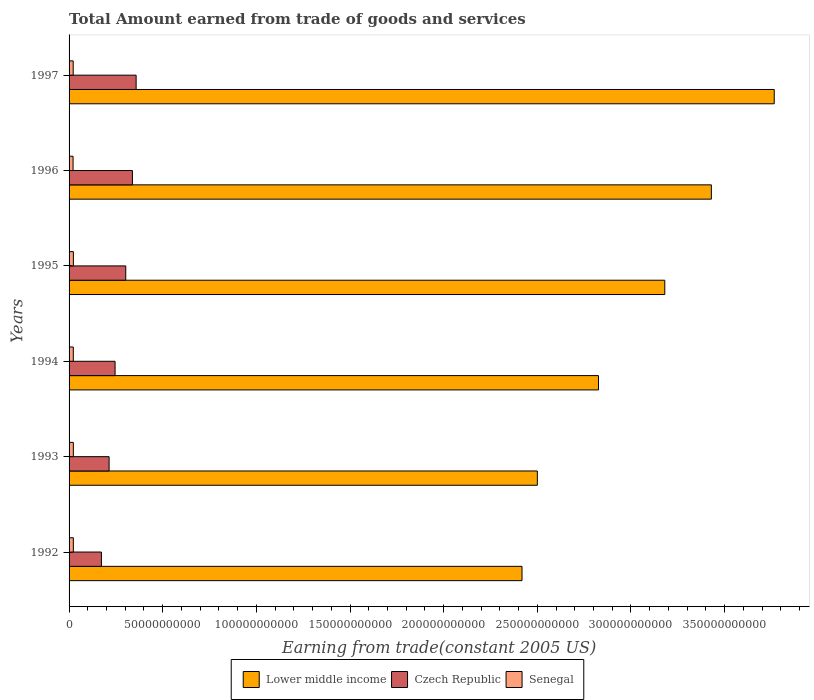How many bars are there on the 3rd tick from the bottom?
Your answer should be compact. 3. What is the total amount earned by trading goods and services in Senegal in 1996?
Offer a terse response. 2.13e+09. Across all years, what is the maximum total amount earned by trading goods and services in Lower middle income?
Provide a short and direct response. 3.76e+11. Across all years, what is the minimum total amount earned by trading goods and services in Senegal?
Keep it short and to the point. 2.13e+09. In which year was the total amount earned by trading goods and services in Lower middle income maximum?
Offer a terse response. 1997. What is the total total amount earned by trading goods and services in Senegal in the graph?
Ensure brevity in your answer.  1.34e+1. What is the difference between the total amount earned by trading goods and services in Senegal in 1993 and that in 1994?
Provide a succinct answer. 2.93e+07. What is the difference between the total amount earned by trading goods and services in Lower middle income in 1992 and the total amount earned by trading goods and services in Senegal in 1994?
Make the answer very short. 2.40e+11. What is the average total amount earned by trading goods and services in Senegal per year?
Offer a very short reply. 2.24e+09. In the year 1996, what is the difference between the total amount earned by trading goods and services in Czech Republic and total amount earned by trading goods and services in Senegal?
Offer a very short reply. 3.17e+1. What is the ratio of the total amount earned by trading goods and services in Czech Republic in 1992 to that in 1996?
Offer a very short reply. 0.51. What is the difference between the highest and the second highest total amount earned by trading goods and services in Lower middle income?
Your answer should be compact. 3.36e+1. What is the difference between the highest and the lowest total amount earned by trading goods and services in Czech Republic?
Ensure brevity in your answer.  1.85e+1. In how many years, is the total amount earned by trading goods and services in Lower middle income greater than the average total amount earned by trading goods and services in Lower middle income taken over all years?
Make the answer very short. 3. What does the 1st bar from the top in 1997 represents?
Your response must be concise. Senegal. What does the 3rd bar from the bottom in 1993 represents?
Provide a succinct answer. Senegal. Is it the case that in every year, the sum of the total amount earned by trading goods and services in Czech Republic and total amount earned by trading goods and services in Lower middle income is greater than the total amount earned by trading goods and services in Senegal?
Provide a short and direct response. Yes. Are all the bars in the graph horizontal?
Your response must be concise. Yes. What is the difference between two consecutive major ticks on the X-axis?
Your response must be concise. 5.00e+1. Are the values on the major ticks of X-axis written in scientific E-notation?
Keep it short and to the point. No. Does the graph contain any zero values?
Your response must be concise. No. Does the graph contain grids?
Make the answer very short. No. Where does the legend appear in the graph?
Offer a very short reply. Bottom center. How many legend labels are there?
Provide a succinct answer. 3. How are the legend labels stacked?
Your answer should be very brief. Horizontal. What is the title of the graph?
Make the answer very short. Total Amount earned from trade of goods and services. Does "Sudan" appear as one of the legend labels in the graph?
Provide a succinct answer. No. What is the label or title of the X-axis?
Offer a terse response. Earning from trade(constant 2005 US). What is the label or title of the Y-axis?
Your answer should be compact. Years. What is the Earning from trade(constant 2005 US) of Lower middle income in 1992?
Keep it short and to the point. 2.42e+11. What is the Earning from trade(constant 2005 US) of Czech Republic in 1992?
Your response must be concise. 1.73e+1. What is the Earning from trade(constant 2005 US) in Senegal in 1992?
Your answer should be very brief. 2.28e+09. What is the Earning from trade(constant 2005 US) in Lower middle income in 1993?
Offer a very short reply. 2.50e+11. What is the Earning from trade(constant 2005 US) of Czech Republic in 1993?
Ensure brevity in your answer.  2.14e+1. What is the Earning from trade(constant 2005 US) in Senegal in 1993?
Keep it short and to the point. 2.28e+09. What is the Earning from trade(constant 2005 US) of Lower middle income in 1994?
Make the answer very short. 2.83e+11. What is the Earning from trade(constant 2005 US) of Czech Republic in 1994?
Provide a succinct answer. 2.46e+1. What is the Earning from trade(constant 2005 US) in Senegal in 1994?
Ensure brevity in your answer.  2.25e+09. What is the Earning from trade(constant 2005 US) of Lower middle income in 1995?
Make the answer very short. 3.18e+11. What is the Earning from trade(constant 2005 US) in Czech Republic in 1995?
Provide a succinct answer. 3.03e+1. What is the Earning from trade(constant 2005 US) in Senegal in 1995?
Give a very brief answer. 2.29e+09. What is the Earning from trade(constant 2005 US) of Lower middle income in 1996?
Your response must be concise. 3.43e+11. What is the Earning from trade(constant 2005 US) of Czech Republic in 1996?
Offer a terse response. 3.38e+1. What is the Earning from trade(constant 2005 US) in Senegal in 1996?
Ensure brevity in your answer.  2.13e+09. What is the Earning from trade(constant 2005 US) in Lower middle income in 1997?
Make the answer very short. 3.76e+11. What is the Earning from trade(constant 2005 US) of Czech Republic in 1997?
Your answer should be very brief. 3.58e+1. What is the Earning from trade(constant 2005 US) of Senegal in 1997?
Provide a succinct answer. 2.20e+09. Across all years, what is the maximum Earning from trade(constant 2005 US) in Lower middle income?
Your response must be concise. 3.76e+11. Across all years, what is the maximum Earning from trade(constant 2005 US) of Czech Republic?
Your response must be concise. 3.58e+1. Across all years, what is the maximum Earning from trade(constant 2005 US) in Senegal?
Your answer should be very brief. 2.29e+09. Across all years, what is the minimum Earning from trade(constant 2005 US) of Lower middle income?
Give a very brief answer. 2.42e+11. Across all years, what is the minimum Earning from trade(constant 2005 US) in Czech Republic?
Your answer should be compact. 1.73e+1. Across all years, what is the minimum Earning from trade(constant 2005 US) of Senegal?
Keep it short and to the point. 2.13e+09. What is the total Earning from trade(constant 2005 US) in Lower middle income in the graph?
Provide a short and direct response. 1.81e+12. What is the total Earning from trade(constant 2005 US) in Czech Republic in the graph?
Your answer should be very brief. 1.63e+11. What is the total Earning from trade(constant 2005 US) in Senegal in the graph?
Keep it short and to the point. 1.34e+1. What is the difference between the Earning from trade(constant 2005 US) of Lower middle income in 1992 and that in 1993?
Give a very brief answer. -8.19e+09. What is the difference between the Earning from trade(constant 2005 US) in Czech Republic in 1992 and that in 1993?
Provide a short and direct response. -4.10e+09. What is the difference between the Earning from trade(constant 2005 US) in Senegal in 1992 and that in 1993?
Your response must be concise. -6.57e+06. What is the difference between the Earning from trade(constant 2005 US) of Lower middle income in 1992 and that in 1994?
Offer a terse response. -4.08e+1. What is the difference between the Earning from trade(constant 2005 US) in Czech Republic in 1992 and that in 1994?
Offer a very short reply. -7.30e+09. What is the difference between the Earning from trade(constant 2005 US) in Senegal in 1992 and that in 1994?
Provide a short and direct response. 2.27e+07. What is the difference between the Earning from trade(constant 2005 US) of Lower middle income in 1992 and that in 1995?
Provide a short and direct response. -7.62e+1. What is the difference between the Earning from trade(constant 2005 US) in Czech Republic in 1992 and that in 1995?
Your answer should be compact. -1.30e+1. What is the difference between the Earning from trade(constant 2005 US) in Senegal in 1992 and that in 1995?
Keep it short and to the point. -1.78e+07. What is the difference between the Earning from trade(constant 2005 US) of Lower middle income in 1992 and that in 1996?
Your answer should be very brief. -1.01e+11. What is the difference between the Earning from trade(constant 2005 US) of Czech Republic in 1992 and that in 1996?
Your answer should be very brief. -1.66e+1. What is the difference between the Earning from trade(constant 2005 US) of Senegal in 1992 and that in 1996?
Make the answer very short. 1.47e+08. What is the difference between the Earning from trade(constant 2005 US) in Lower middle income in 1992 and that in 1997?
Your answer should be very brief. -1.35e+11. What is the difference between the Earning from trade(constant 2005 US) in Czech Republic in 1992 and that in 1997?
Keep it short and to the point. -1.85e+1. What is the difference between the Earning from trade(constant 2005 US) in Senegal in 1992 and that in 1997?
Ensure brevity in your answer.  8.05e+07. What is the difference between the Earning from trade(constant 2005 US) of Lower middle income in 1993 and that in 1994?
Offer a terse response. -3.26e+1. What is the difference between the Earning from trade(constant 2005 US) of Czech Republic in 1993 and that in 1994?
Make the answer very short. -3.20e+09. What is the difference between the Earning from trade(constant 2005 US) in Senegal in 1993 and that in 1994?
Ensure brevity in your answer.  2.93e+07. What is the difference between the Earning from trade(constant 2005 US) in Lower middle income in 1993 and that in 1995?
Make the answer very short. -6.80e+1. What is the difference between the Earning from trade(constant 2005 US) in Czech Republic in 1993 and that in 1995?
Provide a short and direct response. -8.89e+09. What is the difference between the Earning from trade(constant 2005 US) of Senegal in 1993 and that in 1995?
Ensure brevity in your answer.  -1.12e+07. What is the difference between the Earning from trade(constant 2005 US) in Lower middle income in 1993 and that in 1996?
Provide a short and direct response. -9.29e+1. What is the difference between the Earning from trade(constant 2005 US) of Czech Republic in 1993 and that in 1996?
Make the answer very short. -1.25e+1. What is the difference between the Earning from trade(constant 2005 US) of Senegal in 1993 and that in 1996?
Your response must be concise. 1.54e+08. What is the difference between the Earning from trade(constant 2005 US) in Lower middle income in 1993 and that in 1997?
Your response must be concise. -1.26e+11. What is the difference between the Earning from trade(constant 2005 US) of Czech Republic in 1993 and that in 1997?
Offer a terse response. -1.44e+1. What is the difference between the Earning from trade(constant 2005 US) in Senegal in 1993 and that in 1997?
Ensure brevity in your answer.  8.71e+07. What is the difference between the Earning from trade(constant 2005 US) of Lower middle income in 1994 and that in 1995?
Offer a terse response. -3.54e+1. What is the difference between the Earning from trade(constant 2005 US) in Czech Republic in 1994 and that in 1995?
Make the answer very short. -5.69e+09. What is the difference between the Earning from trade(constant 2005 US) in Senegal in 1994 and that in 1995?
Make the answer very short. -4.05e+07. What is the difference between the Earning from trade(constant 2005 US) in Lower middle income in 1994 and that in 1996?
Offer a terse response. -6.03e+1. What is the difference between the Earning from trade(constant 2005 US) in Czech Republic in 1994 and that in 1996?
Keep it short and to the point. -9.26e+09. What is the difference between the Earning from trade(constant 2005 US) of Senegal in 1994 and that in 1996?
Your response must be concise. 1.24e+08. What is the difference between the Earning from trade(constant 2005 US) of Lower middle income in 1994 and that in 1997?
Your response must be concise. -9.38e+1. What is the difference between the Earning from trade(constant 2005 US) of Czech Republic in 1994 and that in 1997?
Your answer should be very brief. -1.12e+1. What is the difference between the Earning from trade(constant 2005 US) in Senegal in 1994 and that in 1997?
Provide a succinct answer. 5.78e+07. What is the difference between the Earning from trade(constant 2005 US) in Lower middle income in 1995 and that in 1996?
Provide a succinct answer. -2.49e+1. What is the difference between the Earning from trade(constant 2005 US) in Czech Republic in 1995 and that in 1996?
Your answer should be very brief. -3.56e+09. What is the difference between the Earning from trade(constant 2005 US) of Senegal in 1995 and that in 1996?
Your response must be concise. 1.65e+08. What is the difference between the Earning from trade(constant 2005 US) of Lower middle income in 1995 and that in 1997?
Provide a short and direct response. -5.84e+1. What is the difference between the Earning from trade(constant 2005 US) in Czech Republic in 1995 and that in 1997?
Keep it short and to the point. -5.54e+09. What is the difference between the Earning from trade(constant 2005 US) of Senegal in 1995 and that in 1997?
Provide a short and direct response. 9.83e+07. What is the difference between the Earning from trade(constant 2005 US) in Lower middle income in 1996 and that in 1997?
Your answer should be very brief. -3.36e+1. What is the difference between the Earning from trade(constant 2005 US) in Czech Republic in 1996 and that in 1997?
Ensure brevity in your answer.  -1.97e+09. What is the difference between the Earning from trade(constant 2005 US) of Senegal in 1996 and that in 1997?
Offer a terse response. -6.64e+07. What is the difference between the Earning from trade(constant 2005 US) in Lower middle income in 1992 and the Earning from trade(constant 2005 US) in Czech Republic in 1993?
Ensure brevity in your answer.  2.20e+11. What is the difference between the Earning from trade(constant 2005 US) of Lower middle income in 1992 and the Earning from trade(constant 2005 US) of Senegal in 1993?
Your answer should be compact. 2.40e+11. What is the difference between the Earning from trade(constant 2005 US) of Czech Republic in 1992 and the Earning from trade(constant 2005 US) of Senegal in 1993?
Offer a terse response. 1.50e+1. What is the difference between the Earning from trade(constant 2005 US) of Lower middle income in 1992 and the Earning from trade(constant 2005 US) of Czech Republic in 1994?
Keep it short and to the point. 2.17e+11. What is the difference between the Earning from trade(constant 2005 US) of Lower middle income in 1992 and the Earning from trade(constant 2005 US) of Senegal in 1994?
Give a very brief answer. 2.40e+11. What is the difference between the Earning from trade(constant 2005 US) in Czech Republic in 1992 and the Earning from trade(constant 2005 US) in Senegal in 1994?
Keep it short and to the point. 1.50e+1. What is the difference between the Earning from trade(constant 2005 US) in Lower middle income in 1992 and the Earning from trade(constant 2005 US) in Czech Republic in 1995?
Your response must be concise. 2.12e+11. What is the difference between the Earning from trade(constant 2005 US) of Lower middle income in 1992 and the Earning from trade(constant 2005 US) of Senegal in 1995?
Your answer should be very brief. 2.40e+11. What is the difference between the Earning from trade(constant 2005 US) in Czech Republic in 1992 and the Earning from trade(constant 2005 US) in Senegal in 1995?
Ensure brevity in your answer.  1.50e+1. What is the difference between the Earning from trade(constant 2005 US) in Lower middle income in 1992 and the Earning from trade(constant 2005 US) in Czech Republic in 1996?
Make the answer very short. 2.08e+11. What is the difference between the Earning from trade(constant 2005 US) of Lower middle income in 1992 and the Earning from trade(constant 2005 US) of Senegal in 1996?
Give a very brief answer. 2.40e+11. What is the difference between the Earning from trade(constant 2005 US) of Czech Republic in 1992 and the Earning from trade(constant 2005 US) of Senegal in 1996?
Your answer should be very brief. 1.51e+1. What is the difference between the Earning from trade(constant 2005 US) in Lower middle income in 1992 and the Earning from trade(constant 2005 US) in Czech Republic in 1997?
Make the answer very short. 2.06e+11. What is the difference between the Earning from trade(constant 2005 US) of Lower middle income in 1992 and the Earning from trade(constant 2005 US) of Senegal in 1997?
Give a very brief answer. 2.40e+11. What is the difference between the Earning from trade(constant 2005 US) in Czech Republic in 1992 and the Earning from trade(constant 2005 US) in Senegal in 1997?
Ensure brevity in your answer.  1.51e+1. What is the difference between the Earning from trade(constant 2005 US) of Lower middle income in 1993 and the Earning from trade(constant 2005 US) of Czech Republic in 1994?
Your answer should be compact. 2.25e+11. What is the difference between the Earning from trade(constant 2005 US) of Lower middle income in 1993 and the Earning from trade(constant 2005 US) of Senegal in 1994?
Give a very brief answer. 2.48e+11. What is the difference between the Earning from trade(constant 2005 US) of Czech Republic in 1993 and the Earning from trade(constant 2005 US) of Senegal in 1994?
Ensure brevity in your answer.  1.91e+1. What is the difference between the Earning from trade(constant 2005 US) of Lower middle income in 1993 and the Earning from trade(constant 2005 US) of Czech Republic in 1995?
Ensure brevity in your answer.  2.20e+11. What is the difference between the Earning from trade(constant 2005 US) in Lower middle income in 1993 and the Earning from trade(constant 2005 US) in Senegal in 1995?
Ensure brevity in your answer.  2.48e+11. What is the difference between the Earning from trade(constant 2005 US) in Czech Republic in 1993 and the Earning from trade(constant 2005 US) in Senegal in 1995?
Give a very brief answer. 1.91e+1. What is the difference between the Earning from trade(constant 2005 US) in Lower middle income in 1993 and the Earning from trade(constant 2005 US) in Czech Republic in 1996?
Your response must be concise. 2.16e+11. What is the difference between the Earning from trade(constant 2005 US) of Lower middle income in 1993 and the Earning from trade(constant 2005 US) of Senegal in 1996?
Keep it short and to the point. 2.48e+11. What is the difference between the Earning from trade(constant 2005 US) of Czech Republic in 1993 and the Earning from trade(constant 2005 US) of Senegal in 1996?
Your response must be concise. 1.92e+1. What is the difference between the Earning from trade(constant 2005 US) of Lower middle income in 1993 and the Earning from trade(constant 2005 US) of Czech Republic in 1997?
Give a very brief answer. 2.14e+11. What is the difference between the Earning from trade(constant 2005 US) of Lower middle income in 1993 and the Earning from trade(constant 2005 US) of Senegal in 1997?
Keep it short and to the point. 2.48e+11. What is the difference between the Earning from trade(constant 2005 US) of Czech Republic in 1993 and the Earning from trade(constant 2005 US) of Senegal in 1997?
Your answer should be very brief. 1.92e+1. What is the difference between the Earning from trade(constant 2005 US) in Lower middle income in 1994 and the Earning from trade(constant 2005 US) in Czech Republic in 1995?
Ensure brevity in your answer.  2.52e+11. What is the difference between the Earning from trade(constant 2005 US) of Lower middle income in 1994 and the Earning from trade(constant 2005 US) of Senegal in 1995?
Your answer should be very brief. 2.80e+11. What is the difference between the Earning from trade(constant 2005 US) of Czech Republic in 1994 and the Earning from trade(constant 2005 US) of Senegal in 1995?
Ensure brevity in your answer.  2.23e+1. What is the difference between the Earning from trade(constant 2005 US) in Lower middle income in 1994 and the Earning from trade(constant 2005 US) in Czech Republic in 1996?
Keep it short and to the point. 2.49e+11. What is the difference between the Earning from trade(constant 2005 US) of Lower middle income in 1994 and the Earning from trade(constant 2005 US) of Senegal in 1996?
Give a very brief answer. 2.81e+11. What is the difference between the Earning from trade(constant 2005 US) in Czech Republic in 1994 and the Earning from trade(constant 2005 US) in Senegal in 1996?
Give a very brief answer. 2.24e+1. What is the difference between the Earning from trade(constant 2005 US) in Lower middle income in 1994 and the Earning from trade(constant 2005 US) in Czech Republic in 1997?
Provide a succinct answer. 2.47e+11. What is the difference between the Earning from trade(constant 2005 US) of Lower middle income in 1994 and the Earning from trade(constant 2005 US) of Senegal in 1997?
Keep it short and to the point. 2.80e+11. What is the difference between the Earning from trade(constant 2005 US) in Czech Republic in 1994 and the Earning from trade(constant 2005 US) in Senegal in 1997?
Keep it short and to the point. 2.24e+1. What is the difference between the Earning from trade(constant 2005 US) of Lower middle income in 1995 and the Earning from trade(constant 2005 US) of Czech Republic in 1996?
Ensure brevity in your answer.  2.84e+11. What is the difference between the Earning from trade(constant 2005 US) of Lower middle income in 1995 and the Earning from trade(constant 2005 US) of Senegal in 1996?
Make the answer very short. 3.16e+11. What is the difference between the Earning from trade(constant 2005 US) of Czech Republic in 1995 and the Earning from trade(constant 2005 US) of Senegal in 1996?
Provide a short and direct response. 2.81e+1. What is the difference between the Earning from trade(constant 2005 US) in Lower middle income in 1995 and the Earning from trade(constant 2005 US) in Czech Republic in 1997?
Make the answer very short. 2.82e+11. What is the difference between the Earning from trade(constant 2005 US) in Lower middle income in 1995 and the Earning from trade(constant 2005 US) in Senegal in 1997?
Give a very brief answer. 3.16e+11. What is the difference between the Earning from trade(constant 2005 US) of Czech Republic in 1995 and the Earning from trade(constant 2005 US) of Senegal in 1997?
Make the answer very short. 2.81e+1. What is the difference between the Earning from trade(constant 2005 US) in Lower middle income in 1996 and the Earning from trade(constant 2005 US) in Czech Republic in 1997?
Offer a terse response. 3.07e+11. What is the difference between the Earning from trade(constant 2005 US) in Lower middle income in 1996 and the Earning from trade(constant 2005 US) in Senegal in 1997?
Keep it short and to the point. 3.41e+11. What is the difference between the Earning from trade(constant 2005 US) of Czech Republic in 1996 and the Earning from trade(constant 2005 US) of Senegal in 1997?
Your response must be concise. 3.16e+1. What is the average Earning from trade(constant 2005 US) in Lower middle income per year?
Ensure brevity in your answer.  3.02e+11. What is the average Earning from trade(constant 2005 US) in Czech Republic per year?
Provide a succinct answer. 2.72e+1. What is the average Earning from trade(constant 2005 US) of Senegal per year?
Your answer should be compact. 2.24e+09. In the year 1992, what is the difference between the Earning from trade(constant 2005 US) of Lower middle income and Earning from trade(constant 2005 US) of Czech Republic?
Provide a short and direct response. 2.25e+11. In the year 1992, what is the difference between the Earning from trade(constant 2005 US) in Lower middle income and Earning from trade(constant 2005 US) in Senegal?
Make the answer very short. 2.40e+11. In the year 1992, what is the difference between the Earning from trade(constant 2005 US) in Czech Republic and Earning from trade(constant 2005 US) in Senegal?
Keep it short and to the point. 1.50e+1. In the year 1993, what is the difference between the Earning from trade(constant 2005 US) of Lower middle income and Earning from trade(constant 2005 US) of Czech Republic?
Offer a terse response. 2.29e+11. In the year 1993, what is the difference between the Earning from trade(constant 2005 US) in Lower middle income and Earning from trade(constant 2005 US) in Senegal?
Your answer should be compact. 2.48e+11. In the year 1993, what is the difference between the Earning from trade(constant 2005 US) of Czech Republic and Earning from trade(constant 2005 US) of Senegal?
Offer a terse response. 1.91e+1. In the year 1994, what is the difference between the Earning from trade(constant 2005 US) of Lower middle income and Earning from trade(constant 2005 US) of Czech Republic?
Offer a terse response. 2.58e+11. In the year 1994, what is the difference between the Earning from trade(constant 2005 US) of Lower middle income and Earning from trade(constant 2005 US) of Senegal?
Give a very brief answer. 2.80e+11. In the year 1994, what is the difference between the Earning from trade(constant 2005 US) in Czech Republic and Earning from trade(constant 2005 US) in Senegal?
Your answer should be very brief. 2.23e+1. In the year 1995, what is the difference between the Earning from trade(constant 2005 US) in Lower middle income and Earning from trade(constant 2005 US) in Czech Republic?
Give a very brief answer. 2.88e+11. In the year 1995, what is the difference between the Earning from trade(constant 2005 US) of Lower middle income and Earning from trade(constant 2005 US) of Senegal?
Your answer should be very brief. 3.16e+11. In the year 1995, what is the difference between the Earning from trade(constant 2005 US) of Czech Republic and Earning from trade(constant 2005 US) of Senegal?
Offer a very short reply. 2.80e+1. In the year 1996, what is the difference between the Earning from trade(constant 2005 US) in Lower middle income and Earning from trade(constant 2005 US) in Czech Republic?
Provide a short and direct response. 3.09e+11. In the year 1996, what is the difference between the Earning from trade(constant 2005 US) in Lower middle income and Earning from trade(constant 2005 US) in Senegal?
Offer a terse response. 3.41e+11. In the year 1996, what is the difference between the Earning from trade(constant 2005 US) of Czech Republic and Earning from trade(constant 2005 US) of Senegal?
Make the answer very short. 3.17e+1. In the year 1997, what is the difference between the Earning from trade(constant 2005 US) in Lower middle income and Earning from trade(constant 2005 US) in Czech Republic?
Offer a terse response. 3.41e+11. In the year 1997, what is the difference between the Earning from trade(constant 2005 US) of Lower middle income and Earning from trade(constant 2005 US) of Senegal?
Your response must be concise. 3.74e+11. In the year 1997, what is the difference between the Earning from trade(constant 2005 US) of Czech Republic and Earning from trade(constant 2005 US) of Senegal?
Provide a short and direct response. 3.36e+1. What is the ratio of the Earning from trade(constant 2005 US) of Lower middle income in 1992 to that in 1993?
Your response must be concise. 0.97. What is the ratio of the Earning from trade(constant 2005 US) in Czech Republic in 1992 to that in 1993?
Provide a short and direct response. 0.81. What is the ratio of the Earning from trade(constant 2005 US) in Lower middle income in 1992 to that in 1994?
Offer a very short reply. 0.86. What is the ratio of the Earning from trade(constant 2005 US) in Czech Republic in 1992 to that in 1994?
Provide a short and direct response. 0.7. What is the ratio of the Earning from trade(constant 2005 US) in Lower middle income in 1992 to that in 1995?
Your answer should be compact. 0.76. What is the ratio of the Earning from trade(constant 2005 US) of Czech Republic in 1992 to that in 1995?
Provide a succinct answer. 0.57. What is the ratio of the Earning from trade(constant 2005 US) in Senegal in 1992 to that in 1995?
Give a very brief answer. 0.99. What is the ratio of the Earning from trade(constant 2005 US) in Lower middle income in 1992 to that in 1996?
Ensure brevity in your answer.  0.71. What is the ratio of the Earning from trade(constant 2005 US) in Czech Republic in 1992 to that in 1996?
Ensure brevity in your answer.  0.51. What is the ratio of the Earning from trade(constant 2005 US) in Senegal in 1992 to that in 1996?
Keep it short and to the point. 1.07. What is the ratio of the Earning from trade(constant 2005 US) in Lower middle income in 1992 to that in 1997?
Your answer should be very brief. 0.64. What is the ratio of the Earning from trade(constant 2005 US) of Czech Republic in 1992 to that in 1997?
Make the answer very short. 0.48. What is the ratio of the Earning from trade(constant 2005 US) in Senegal in 1992 to that in 1997?
Provide a succinct answer. 1.04. What is the ratio of the Earning from trade(constant 2005 US) of Lower middle income in 1993 to that in 1994?
Offer a very short reply. 0.88. What is the ratio of the Earning from trade(constant 2005 US) in Czech Republic in 1993 to that in 1994?
Give a very brief answer. 0.87. What is the ratio of the Earning from trade(constant 2005 US) in Senegal in 1993 to that in 1994?
Ensure brevity in your answer.  1.01. What is the ratio of the Earning from trade(constant 2005 US) of Lower middle income in 1993 to that in 1995?
Offer a terse response. 0.79. What is the ratio of the Earning from trade(constant 2005 US) of Czech Republic in 1993 to that in 1995?
Your response must be concise. 0.71. What is the ratio of the Earning from trade(constant 2005 US) of Senegal in 1993 to that in 1995?
Offer a terse response. 1. What is the ratio of the Earning from trade(constant 2005 US) in Lower middle income in 1993 to that in 1996?
Offer a very short reply. 0.73. What is the ratio of the Earning from trade(constant 2005 US) of Czech Republic in 1993 to that in 1996?
Give a very brief answer. 0.63. What is the ratio of the Earning from trade(constant 2005 US) of Senegal in 1993 to that in 1996?
Your answer should be compact. 1.07. What is the ratio of the Earning from trade(constant 2005 US) in Lower middle income in 1993 to that in 1997?
Make the answer very short. 0.66. What is the ratio of the Earning from trade(constant 2005 US) of Czech Republic in 1993 to that in 1997?
Give a very brief answer. 0.6. What is the ratio of the Earning from trade(constant 2005 US) of Senegal in 1993 to that in 1997?
Keep it short and to the point. 1.04. What is the ratio of the Earning from trade(constant 2005 US) of Lower middle income in 1994 to that in 1995?
Give a very brief answer. 0.89. What is the ratio of the Earning from trade(constant 2005 US) of Czech Republic in 1994 to that in 1995?
Provide a short and direct response. 0.81. What is the ratio of the Earning from trade(constant 2005 US) of Senegal in 1994 to that in 1995?
Your response must be concise. 0.98. What is the ratio of the Earning from trade(constant 2005 US) of Lower middle income in 1994 to that in 1996?
Your answer should be compact. 0.82. What is the ratio of the Earning from trade(constant 2005 US) of Czech Republic in 1994 to that in 1996?
Offer a very short reply. 0.73. What is the ratio of the Earning from trade(constant 2005 US) in Senegal in 1994 to that in 1996?
Offer a terse response. 1.06. What is the ratio of the Earning from trade(constant 2005 US) in Lower middle income in 1994 to that in 1997?
Provide a succinct answer. 0.75. What is the ratio of the Earning from trade(constant 2005 US) of Czech Republic in 1994 to that in 1997?
Your response must be concise. 0.69. What is the ratio of the Earning from trade(constant 2005 US) in Senegal in 1994 to that in 1997?
Your answer should be very brief. 1.03. What is the ratio of the Earning from trade(constant 2005 US) in Lower middle income in 1995 to that in 1996?
Your response must be concise. 0.93. What is the ratio of the Earning from trade(constant 2005 US) in Czech Republic in 1995 to that in 1996?
Your response must be concise. 0.89. What is the ratio of the Earning from trade(constant 2005 US) in Senegal in 1995 to that in 1996?
Offer a very short reply. 1.08. What is the ratio of the Earning from trade(constant 2005 US) of Lower middle income in 1995 to that in 1997?
Offer a very short reply. 0.84. What is the ratio of the Earning from trade(constant 2005 US) in Czech Republic in 1995 to that in 1997?
Your answer should be very brief. 0.85. What is the ratio of the Earning from trade(constant 2005 US) in Senegal in 1995 to that in 1997?
Give a very brief answer. 1.04. What is the ratio of the Earning from trade(constant 2005 US) of Lower middle income in 1996 to that in 1997?
Provide a short and direct response. 0.91. What is the ratio of the Earning from trade(constant 2005 US) in Czech Republic in 1996 to that in 1997?
Make the answer very short. 0.94. What is the ratio of the Earning from trade(constant 2005 US) in Senegal in 1996 to that in 1997?
Offer a terse response. 0.97. What is the difference between the highest and the second highest Earning from trade(constant 2005 US) of Lower middle income?
Provide a short and direct response. 3.36e+1. What is the difference between the highest and the second highest Earning from trade(constant 2005 US) in Czech Republic?
Your response must be concise. 1.97e+09. What is the difference between the highest and the second highest Earning from trade(constant 2005 US) in Senegal?
Give a very brief answer. 1.12e+07. What is the difference between the highest and the lowest Earning from trade(constant 2005 US) of Lower middle income?
Ensure brevity in your answer.  1.35e+11. What is the difference between the highest and the lowest Earning from trade(constant 2005 US) in Czech Republic?
Keep it short and to the point. 1.85e+1. What is the difference between the highest and the lowest Earning from trade(constant 2005 US) in Senegal?
Offer a very short reply. 1.65e+08. 